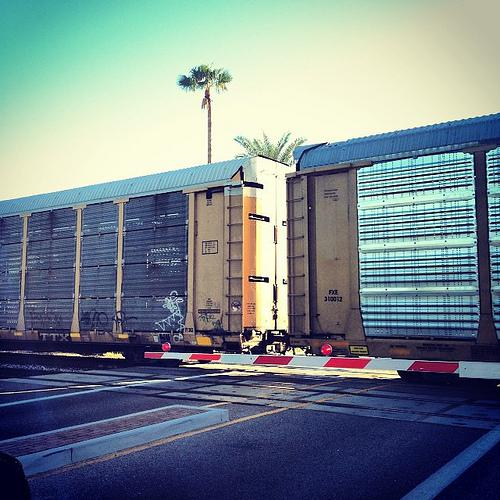Question: where are the trees?
Choices:
A. In the background.
B. Behind train.
C. On the edge of the field.
D. On the left side.
Answer with the letter. Answer: B 